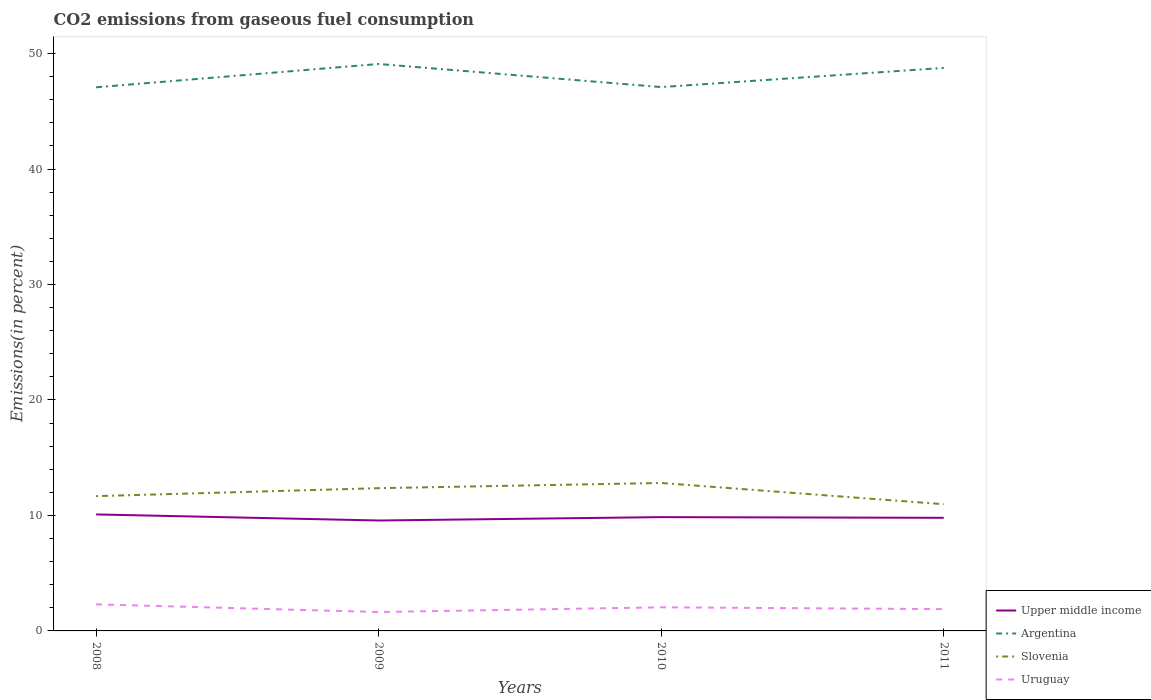How many different coloured lines are there?
Offer a terse response. 4. Is the number of lines equal to the number of legend labels?
Give a very brief answer. Yes. Across all years, what is the maximum total CO2 emitted in Uruguay?
Give a very brief answer. 1.63. In which year was the total CO2 emitted in Upper middle income maximum?
Give a very brief answer. 2009. What is the total total CO2 emitted in Uruguay in the graph?
Your response must be concise. 0.42. What is the difference between the highest and the second highest total CO2 emitted in Upper middle income?
Offer a very short reply. 0.53. What is the difference between the highest and the lowest total CO2 emitted in Upper middle income?
Make the answer very short. 2. Is the total CO2 emitted in Slovenia strictly greater than the total CO2 emitted in Uruguay over the years?
Offer a very short reply. No. How many years are there in the graph?
Offer a terse response. 4. What is the difference between two consecutive major ticks on the Y-axis?
Keep it short and to the point. 10. Are the values on the major ticks of Y-axis written in scientific E-notation?
Offer a terse response. No. Where does the legend appear in the graph?
Ensure brevity in your answer.  Bottom right. How many legend labels are there?
Give a very brief answer. 4. How are the legend labels stacked?
Ensure brevity in your answer.  Vertical. What is the title of the graph?
Give a very brief answer. CO2 emissions from gaseous fuel consumption. What is the label or title of the X-axis?
Give a very brief answer. Years. What is the label or title of the Y-axis?
Offer a very short reply. Emissions(in percent). What is the Emissions(in percent) of Upper middle income in 2008?
Provide a short and direct response. 10.09. What is the Emissions(in percent) in Argentina in 2008?
Keep it short and to the point. 47.08. What is the Emissions(in percent) in Slovenia in 2008?
Make the answer very short. 11.67. What is the Emissions(in percent) of Uruguay in 2008?
Ensure brevity in your answer.  2.3. What is the Emissions(in percent) in Upper middle income in 2009?
Your response must be concise. 9.56. What is the Emissions(in percent) in Argentina in 2009?
Provide a short and direct response. 49.1. What is the Emissions(in percent) in Slovenia in 2009?
Provide a succinct answer. 12.36. What is the Emissions(in percent) of Uruguay in 2009?
Offer a terse response. 1.63. What is the Emissions(in percent) in Upper middle income in 2010?
Your answer should be compact. 9.86. What is the Emissions(in percent) in Argentina in 2010?
Ensure brevity in your answer.  47.1. What is the Emissions(in percent) of Slovenia in 2010?
Offer a terse response. 12.81. What is the Emissions(in percent) of Uruguay in 2010?
Offer a terse response. 2.05. What is the Emissions(in percent) of Upper middle income in 2011?
Give a very brief answer. 9.8. What is the Emissions(in percent) of Argentina in 2011?
Provide a succinct answer. 48.76. What is the Emissions(in percent) in Slovenia in 2011?
Make the answer very short. 10.97. What is the Emissions(in percent) in Uruguay in 2011?
Your answer should be very brief. 1.89. Across all years, what is the maximum Emissions(in percent) of Upper middle income?
Provide a short and direct response. 10.09. Across all years, what is the maximum Emissions(in percent) of Argentina?
Offer a terse response. 49.1. Across all years, what is the maximum Emissions(in percent) of Slovenia?
Offer a very short reply. 12.81. Across all years, what is the maximum Emissions(in percent) of Uruguay?
Your answer should be very brief. 2.3. Across all years, what is the minimum Emissions(in percent) of Upper middle income?
Keep it short and to the point. 9.56. Across all years, what is the minimum Emissions(in percent) in Argentina?
Provide a succinct answer. 47.08. Across all years, what is the minimum Emissions(in percent) in Slovenia?
Offer a terse response. 10.97. Across all years, what is the minimum Emissions(in percent) of Uruguay?
Your response must be concise. 1.63. What is the total Emissions(in percent) in Upper middle income in the graph?
Keep it short and to the point. 39.3. What is the total Emissions(in percent) of Argentina in the graph?
Ensure brevity in your answer.  192.04. What is the total Emissions(in percent) of Slovenia in the graph?
Offer a very short reply. 47.82. What is the total Emissions(in percent) in Uruguay in the graph?
Provide a short and direct response. 7.87. What is the difference between the Emissions(in percent) in Upper middle income in 2008 and that in 2009?
Offer a very short reply. 0.53. What is the difference between the Emissions(in percent) in Argentina in 2008 and that in 2009?
Make the answer very short. -2.02. What is the difference between the Emissions(in percent) in Slovenia in 2008 and that in 2009?
Give a very brief answer. -0.69. What is the difference between the Emissions(in percent) in Uruguay in 2008 and that in 2009?
Offer a very short reply. 0.67. What is the difference between the Emissions(in percent) of Upper middle income in 2008 and that in 2010?
Offer a terse response. 0.23. What is the difference between the Emissions(in percent) of Argentina in 2008 and that in 2010?
Give a very brief answer. -0.02. What is the difference between the Emissions(in percent) in Slovenia in 2008 and that in 2010?
Your answer should be very brief. -1.14. What is the difference between the Emissions(in percent) in Uruguay in 2008 and that in 2010?
Give a very brief answer. 0.26. What is the difference between the Emissions(in percent) in Upper middle income in 2008 and that in 2011?
Your answer should be compact. 0.29. What is the difference between the Emissions(in percent) of Argentina in 2008 and that in 2011?
Your answer should be very brief. -1.68. What is the difference between the Emissions(in percent) of Slovenia in 2008 and that in 2011?
Your response must be concise. 0.7. What is the difference between the Emissions(in percent) of Uruguay in 2008 and that in 2011?
Provide a short and direct response. 0.42. What is the difference between the Emissions(in percent) of Upper middle income in 2009 and that in 2010?
Provide a succinct answer. -0.29. What is the difference between the Emissions(in percent) of Argentina in 2009 and that in 2010?
Your answer should be compact. 2. What is the difference between the Emissions(in percent) of Slovenia in 2009 and that in 2010?
Keep it short and to the point. -0.45. What is the difference between the Emissions(in percent) in Uruguay in 2009 and that in 2010?
Provide a succinct answer. -0.41. What is the difference between the Emissions(in percent) of Upper middle income in 2009 and that in 2011?
Offer a terse response. -0.23. What is the difference between the Emissions(in percent) of Argentina in 2009 and that in 2011?
Offer a very short reply. 0.34. What is the difference between the Emissions(in percent) of Slovenia in 2009 and that in 2011?
Offer a terse response. 1.39. What is the difference between the Emissions(in percent) in Uruguay in 2009 and that in 2011?
Your answer should be compact. -0.25. What is the difference between the Emissions(in percent) in Upper middle income in 2010 and that in 2011?
Offer a very short reply. 0.06. What is the difference between the Emissions(in percent) of Argentina in 2010 and that in 2011?
Keep it short and to the point. -1.66. What is the difference between the Emissions(in percent) in Slovenia in 2010 and that in 2011?
Your response must be concise. 1.84. What is the difference between the Emissions(in percent) of Uruguay in 2010 and that in 2011?
Ensure brevity in your answer.  0.16. What is the difference between the Emissions(in percent) in Upper middle income in 2008 and the Emissions(in percent) in Argentina in 2009?
Keep it short and to the point. -39.01. What is the difference between the Emissions(in percent) of Upper middle income in 2008 and the Emissions(in percent) of Slovenia in 2009?
Your answer should be very brief. -2.27. What is the difference between the Emissions(in percent) of Upper middle income in 2008 and the Emissions(in percent) of Uruguay in 2009?
Provide a short and direct response. 8.46. What is the difference between the Emissions(in percent) in Argentina in 2008 and the Emissions(in percent) in Slovenia in 2009?
Give a very brief answer. 34.72. What is the difference between the Emissions(in percent) of Argentina in 2008 and the Emissions(in percent) of Uruguay in 2009?
Make the answer very short. 45.44. What is the difference between the Emissions(in percent) in Slovenia in 2008 and the Emissions(in percent) in Uruguay in 2009?
Ensure brevity in your answer.  10.04. What is the difference between the Emissions(in percent) of Upper middle income in 2008 and the Emissions(in percent) of Argentina in 2010?
Provide a succinct answer. -37.01. What is the difference between the Emissions(in percent) of Upper middle income in 2008 and the Emissions(in percent) of Slovenia in 2010?
Provide a succinct answer. -2.72. What is the difference between the Emissions(in percent) in Upper middle income in 2008 and the Emissions(in percent) in Uruguay in 2010?
Your answer should be compact. 8.04. What is the difference between the Emissions(in percent) in Argentina in 2008 and the Emissions(in percent) in Slovenia in 2010?
Your answer should be very brief. 34.27. What is the difference between the Emissions(in percent) of Argentina in 2008 and the Emissions(in percent) of Uruguay in 2010?
Your answer should be very brief. 45.03. What is the difference between the Emissions(in percent) in Slovenia in 2008 and the Emissions(in percent) in Uruguay in 2010?
Your response must be concise. 9.63. What is the difference between the Emissions(in percent) of Upper middle income in 2008 and the Emissions(in percent) of Argentina in 2011?
Your response must be concise. -38.67. What is the difference between the Emissions(in percent) in Upper middle income in 2008 and the Emissions(in percent) in Slovenia in 2011?
Your response must be concise. -0.88. What is the difference between the Emissions(in percent) in Upper middle income in 2008 and the Emissions(in percent) in Uruguay in 2011?
Offer a very short reply. 8.2. What is the difference between the Emissions(in percent) in Argentina in 2008 and the Emissions(in percent) in Slovenia in 2011?
Provide a short and direct response. 36.11. What is the difference between the Emissions(in percent) in Argentina in 2008 and the Emissions(in percent) in Uruguay in 2011?
Your response must be concise. 45.19. What is the difference between the Emissions(in percent) of Slovenia in 2008 and the Emissions(in percent) of Uruguay in 2011?
Make the answer very short. 9.79. What is the difference between the Emissions(in percent) of Upper middle income in 2009 and the Emissions(in percent) of Argentina in 2010?
Ensure brevity in your answer.  -37.54. What is the difference between the Emissions(in percent) of Upper middle income in 2009 and the Emissions(in percent) of Slovenia in 2010?
Your answer should be compact. -3.25. What is the difference between the Emissions(in percent) of Upper middle income in 2009 and the Emissions(in percent) of Uruguay in 2010?
Provide a succinct answer. 7.52. What is the difference between the Emissions(in percent) of Argentina in 2009 and the Emissions(in percent) of Slovenia in 2010?
Give a very brief answer. 36.29. What is the difference between the Emissions(in percent) in Argentina in 2009 and the Emissions(in percent) in Uruguay in 2010?
Provide a short and direct response. 47.05. What is the difference between the Emissions(in percent) in Slovenia in 2009 and the Emissions(in percent) in Uruguay in 2010?
Your response must be concise. 10.32. What is the difference between the Emissions(in percent) in Upper middle income in 2009 and the Emissions(in percent) in Argentina in 2011?
Offer a terse response. -39.2. What is the difference between the Emissions(in percent) in Upper middle income in 2009 and the Emissions(in percent) in Slovenia in 2011?
Your answer should be compact. -1.41. What is the difference between the Emissions(in percent) of Upper middle income in 2009 and the Emissions(in percent) of Uruguay in 2011?
Ensure brevity in your answer.  7.68. What is the difference between the Emissions(in percent) of Argentina in 2009 and the Emissions(in percent) of Slovenia in 2011?
Make the answer very short. 38.13. What is the difference between the Emissions(in percent) of Argentina in 2009 and the Emissions(in percent) of Uruguay in 2011?
Provide a short and direct response. 47.21. What is the difference between the Emissions(in percent) in Slovenia in 2009 and the Emissions(in percent) in Uruguay in 2011?
Your response must be concise. 10.48. What is the difference between the Emissions(in percent) of Upper middle income in 2010 and the Emissions(in percent) of Argentina in 2011?
Your answer should be very brief. -38.9. What is the difference between the Emissions(in percent) of Upper middle income in 2010 and the Emissions(in percent) of Slovenia in 2011?
Your response must be concise. -1.12. What is the difference between the Emissions(in percent) of Upper middle income in 2010 and the Emissions(in percent) of Uruguay in 2011?
Make the answer very short. 7.97. What is the difference between the Emissions(in percent) in Argentina in 2010 and the Emissions(in percent) in Slovenia in 2011?
Your answer should be compact. 36.13. What is the difference between the Emissions(in percent) in Argentina in 2010 and the Emissions(in percent) in Uruguay in 2011?
Offer a terse response. 45.21. What is the difference between the Emissions(in percent) of Slovenia in 2010 and the Emissions(in percent) of Uruguay in 2011?
Your response must be concise. 10.93. What is the average Emissions(in percent) in Upper middle income per year?
Offer a terse response. 9.83. What is the average Emissions(in percent) of Argentina per year?
Offer a terse response. 48.01. What is the average Emissions(in percent) in Slovenia per year?
Give a very brief answer. 11.96. What is the average Emissions(in percent) of Uruguay per year?
Keep it short and to the point. 1.97. In the year 2008, what is the difference between the Emissions(in percent) of Upper middle income and Emissions(in percent) of Argentina?
Offer a terse response. -36.99. In the year 2008, what is the difference between the Emissions(in percent) of Upper middle income and Emissions(in percent) of Slovenia?
Provide a short and direct response. -1.58. In the year 2008, what is the difference between the Emissions(in percent) in Upper middle income and Emissions(in percent) in Uruguay?
Offer a very short reply. 7.79. In the year 2008, what is the difference between the Emissions(in percent) of Argentina and Emissions(in percent) of Slovenia?
Your response must be concise. 35.41. In the year 2008, what is the difference between the Emissions(in percent) in Argentina and Emissions(in percent) in Uruguay?
Your answer should be compact. 44.78. In the year 2008, what is the difference between the Emissions(in percent) in Slovenia and Emissions(in percent) in Uruguay?
Your answer should be compact. 9.37. In the year 2009, what is the difference between the Emissions(in percent) of Upper middle income and Emissions(in percent) of Argentina?
Keep it short and to the point. -39.54. In the year 2009, what is the difference between the Emissions(in percent) in Upper middle income and Emissions(in percent) in Slovenia?
Keep it short and to the point. -2.8. In the year 2009, what is the difference between the Emissions(in percent) in Upper middle income and Emissions(in percent) in Uruguay?
Give a very brief answer. 7.93. In the year 2009, what is the difference between the Emissions(in percent) of Argentina and Emissions(in percent) of Slovenia?
Keep it short and to the point. 36.74. In the year 2009, what is the difference between the Emissions(in percent) in Argentina and Emissions(in percent) in Uruguay?
Your answer should be very brief. 47.46. In the year 2009, what is the difference between the Emissions(in percent) in Slovenia and Emissions(in percent) in Uruguay?
Keep it short and to the point. 10.73. In the year 2010, what is the difference between the Emissions(in percent) in Upper middle income and Emissions(in percent) in Argentina?
Provide a succinct answer. -37.24. In the year 2010, what is the difference between the Emissions(in percent) in Upper middle income and Emissions(in percent) in Slovenia?
Your answer should be compact. -2.96. In the year 2010, what is the difference between the Emissions(in percent) in Upper middle income and Emissions(in percent) in Uruguay?
Your response must be concise. 7.81. In the year 2010, what is the difference between the Emissions(in percent) in Argentina and Emissions(in percent) in Slovenia?
Offer a terse response. 34.29. In the year 2010, what is the difference between the Emissions(in percent) of Argentina and Emissions(in percent) of Uruguay?
Provide a short and direct response. 45.05. In the year 2010, what is the difference between the Emissions(in percent) in Slovenia and Emissions(in percent) in Uruguay?
Your answer should be very brief. 10.77. In the year 2011, what is the difference between the Emissions(in percent) in Upper middle income and Emissions(in percent) in Argentina?
Offer a very short reply. -38.96. In the year 2011, what is the difference between the Emissions(in percent) in Upper middle income and Emissions(in percent) in Slovenia?
Offer a terse response. -1.18. In the year 2011, what is the difference between the Emissions(in percent) in Upper middle income and Emissions(in percent) in Uruguay?
Ensure brevity in your answer.  7.91. In the year 2011, what is the difference between the Emissions(in percent) of Argentina and Emissions(in percent) of Slovenia?
Keep it short and to the point. 37.79. In the year 2011, what is the difference between the Emissions(in percent) in Argentina and Emissions(in percent) in Uruguay?
Provide a short and direct response. 46.87. In the year 2011, what is the difference between the Emissions(in percent) in Slovenia and Emissions(in percent) in Uruguay?
Keep it short and to the point. 9.09. What is the ratio of the Emissions(in percent) in Upper middle income in 2008 to that in 2009?
Offer a terse response. 1.06. What is the ratio of the Emissions(in percent) in Argentina in 2008 to that in 2009?
Provide a short and direct response. 0.96. What is the ratio of the Emissions(in percent) in Slovenia in 2008 to that in 2009?
Offer a very short reply. 0.94. What is the ratio of the Emissions(in percent) of Uruguay in 2008 to that in 2009?
Ensure brevity in your answer.  1.41. What is the ratio of the Emissions(in percent) of Upper middle income in 2008 to that in 2010?
Keep it short and to the point. 1.02. What is the ratio of the Emissions(in percent) of Slovenia in 2008 to that in 2010?
Keep it short and to the point. 0.91. What is the ratio of the Emissions(in percent) in Uruguay in 2008 to that in 2010?
Keep it short and to the point. 1.13. What is the ratio of the Emissions(in percent) of Upper middle income in 2008 to that in 2011?
Your answer should be compact. 1.03. What is the ratio of the Emissions(in percent) in Argentina in 2008 to that in 2011?
Your answer should be very brief. 0.97. What is the ratio of the Emissions(in percent) in Slovenia in 2008 to that in 2011?
Your response must be concise. 1.06. What is the ratio of the Emissions(in percent) of Uruguay in 2008 to that in 2011?
Make the answer very short. 1.22. What is the ratio of the Emissions(in percent) in Upper middle income in 2009 to that in 2010?
Give a very brief answer. 0.97. What is the ratio of the Emissions(in percent) in Argentina in 2009 to that in 2010?
Provide a short and direct response. 1.04. What is the ratio of the Emissions(in percent) in Uruguay in 2009 to that in 2010?
Provide a succinct answer. 0.8. What is the ratio of the Emissions(in percent) of Upper middle income in 2009 to that in 2011?
Your answer should be compact. 0.98. What is the ratio of the Emissions(in percent) in Argentina in 2009 to that in 2011?
Offer a very short reply. 1.01. What is the ratio of the Emissions(in percent) in Slovenia in 2009 to that in 2011?
Your response must be concise. 1.13. What is the ratio of the Emissions(in percent) of Uruguay in 2009 to that in 2011?
Give a very brief answer. 0.87. What is the ratio of the Emissions(in percent) of Argentina in 2010 to that in 2011?
Provide a succinct answer. 0.97. What is the ratio of the Emissions(in percent) in Slovenia in 2010 to that in 2011?
Provide a short and direct response. 1.17. What is the ratio of the Emissions(in percent) in Uruguay in 2010 to that in 2011?
Provide a succinct answer. 1.08. What is the difference between the highest and the second highest Emissions(in percent) of Upper middle income?
Your answer should be compact. 0.23. What is the difference between the highest and the second highest Emissions(in percent) in Argentina?
Keep it short and to the point. 0.34. What is the difference between the highest and the second highest Emissions(in percent) in Slovenia?
Your answer should be very brief. 0.45. What is the difference between the highest and the second highest Emissions(in percent) in Uruguay?
Make the answer very short. 0.26. What is the difference between the highest and the lowest Emissions(in percent) in Upper middle income?
Make the answer very short. 0.53. What is the difference between the highest and the lowest Emissions(in percent) of Argentina?
Keep it short and to the point. 2.02. What is the difference between the highest and the lowest Emissions(in percent) of Slovenia?
Keep it short and to the point. 1.84. What is the difference between the highest and the lowest Emissions(in percent) in Uruguay?
Offer a terse response. 0.67. 